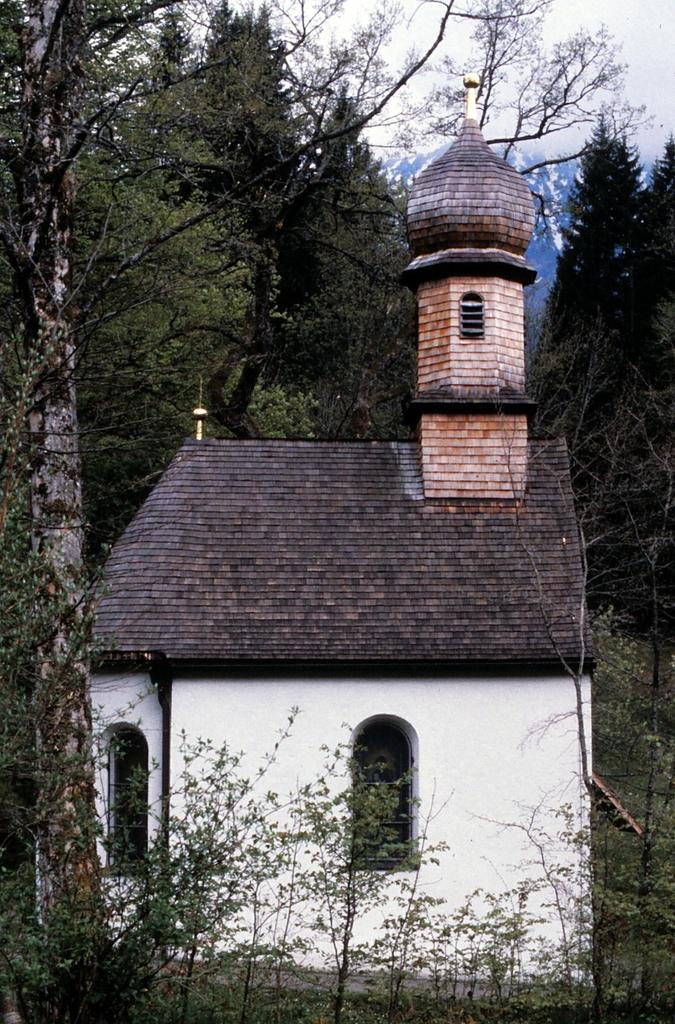What type of structure is present in the image? There is a building in the image. What other natural elements can be seen in the image? There are trees and hills in the image. What is visible in the background of the image? The sky is visible in the image. What type of bulb is growing on the trees in the image? There are no bulbs growing on the trees in the image; only trees are present. 